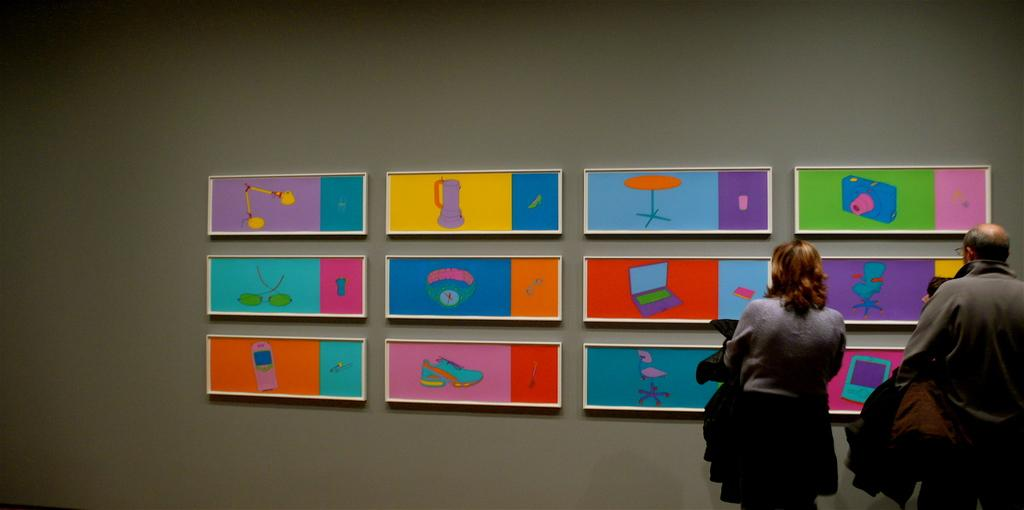What is depicted on the wall in the image? There are arts on the wall in the image. How many people are standing on the right side of the image? There are two members standing on the right side of the image. What color is the wall in the image? The wall is in grey color. Can you tell me where the sun is located in the image? There is no sun present in the image. Are the members wearing masks in the image? There is no indication of masks being worn by the members in the image. 